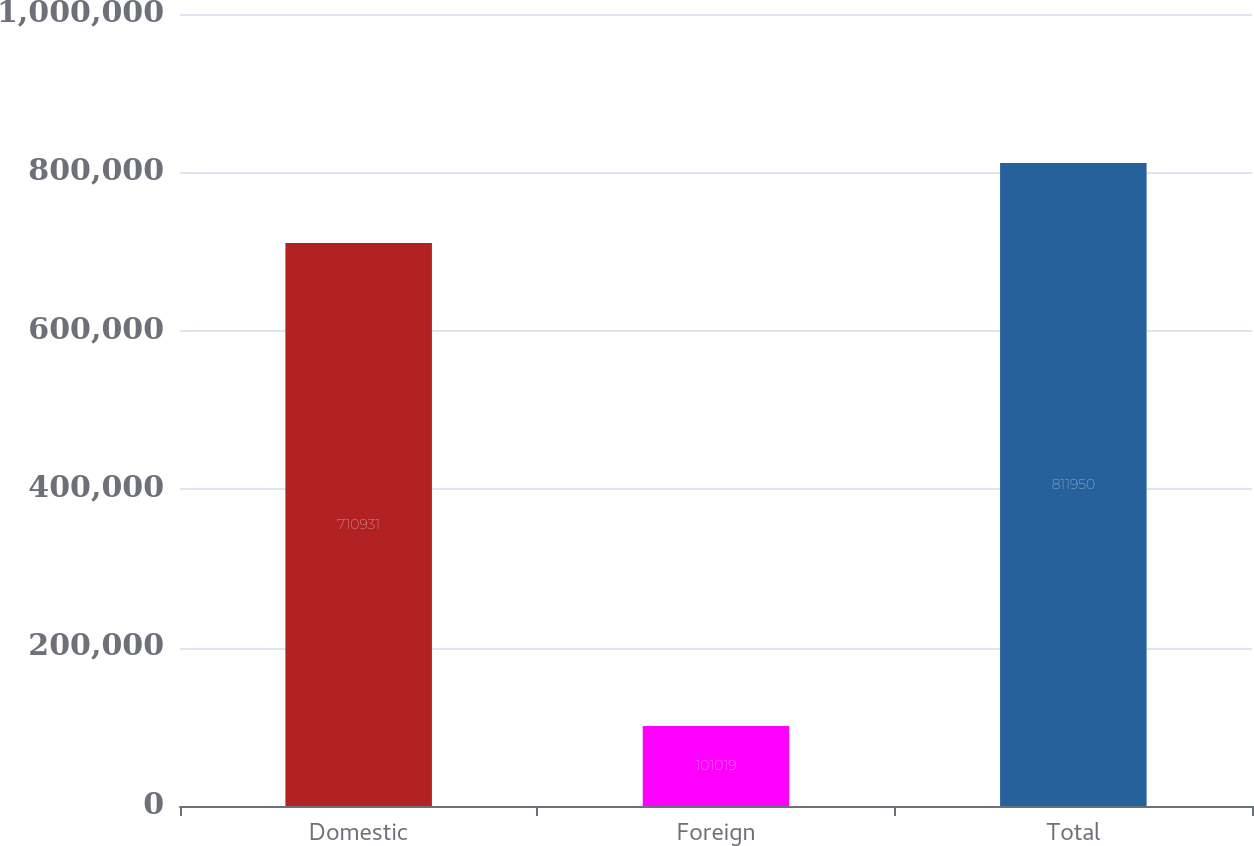Convert chart. <chart><loc_0><loc_0><loc_500><loc_500><bar_chart><fcel>Domestic<fcel>Foreign<fcel>Total<nl><fcel>710931<fcel>101019<fcel>811950<nl></chart> 